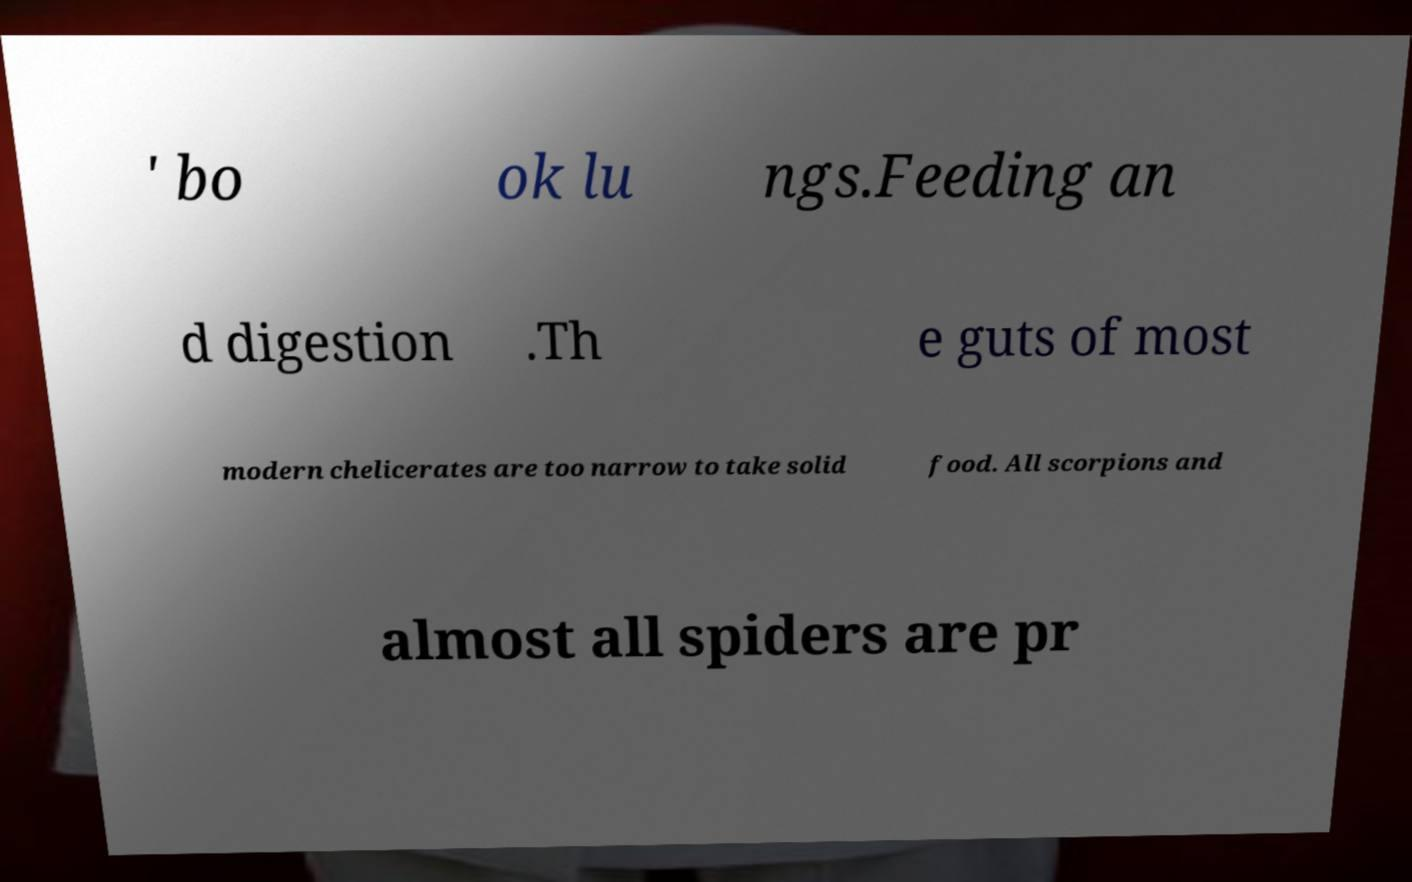There's text embedded in this image that I need extracted. Can you transcribe it verbatim? ' bo ok lu ngs.Feeding an d digestion .Th e guts of most modern chelicerates are too narrow to take solid food. All scorpions and almost all spiders are pr 